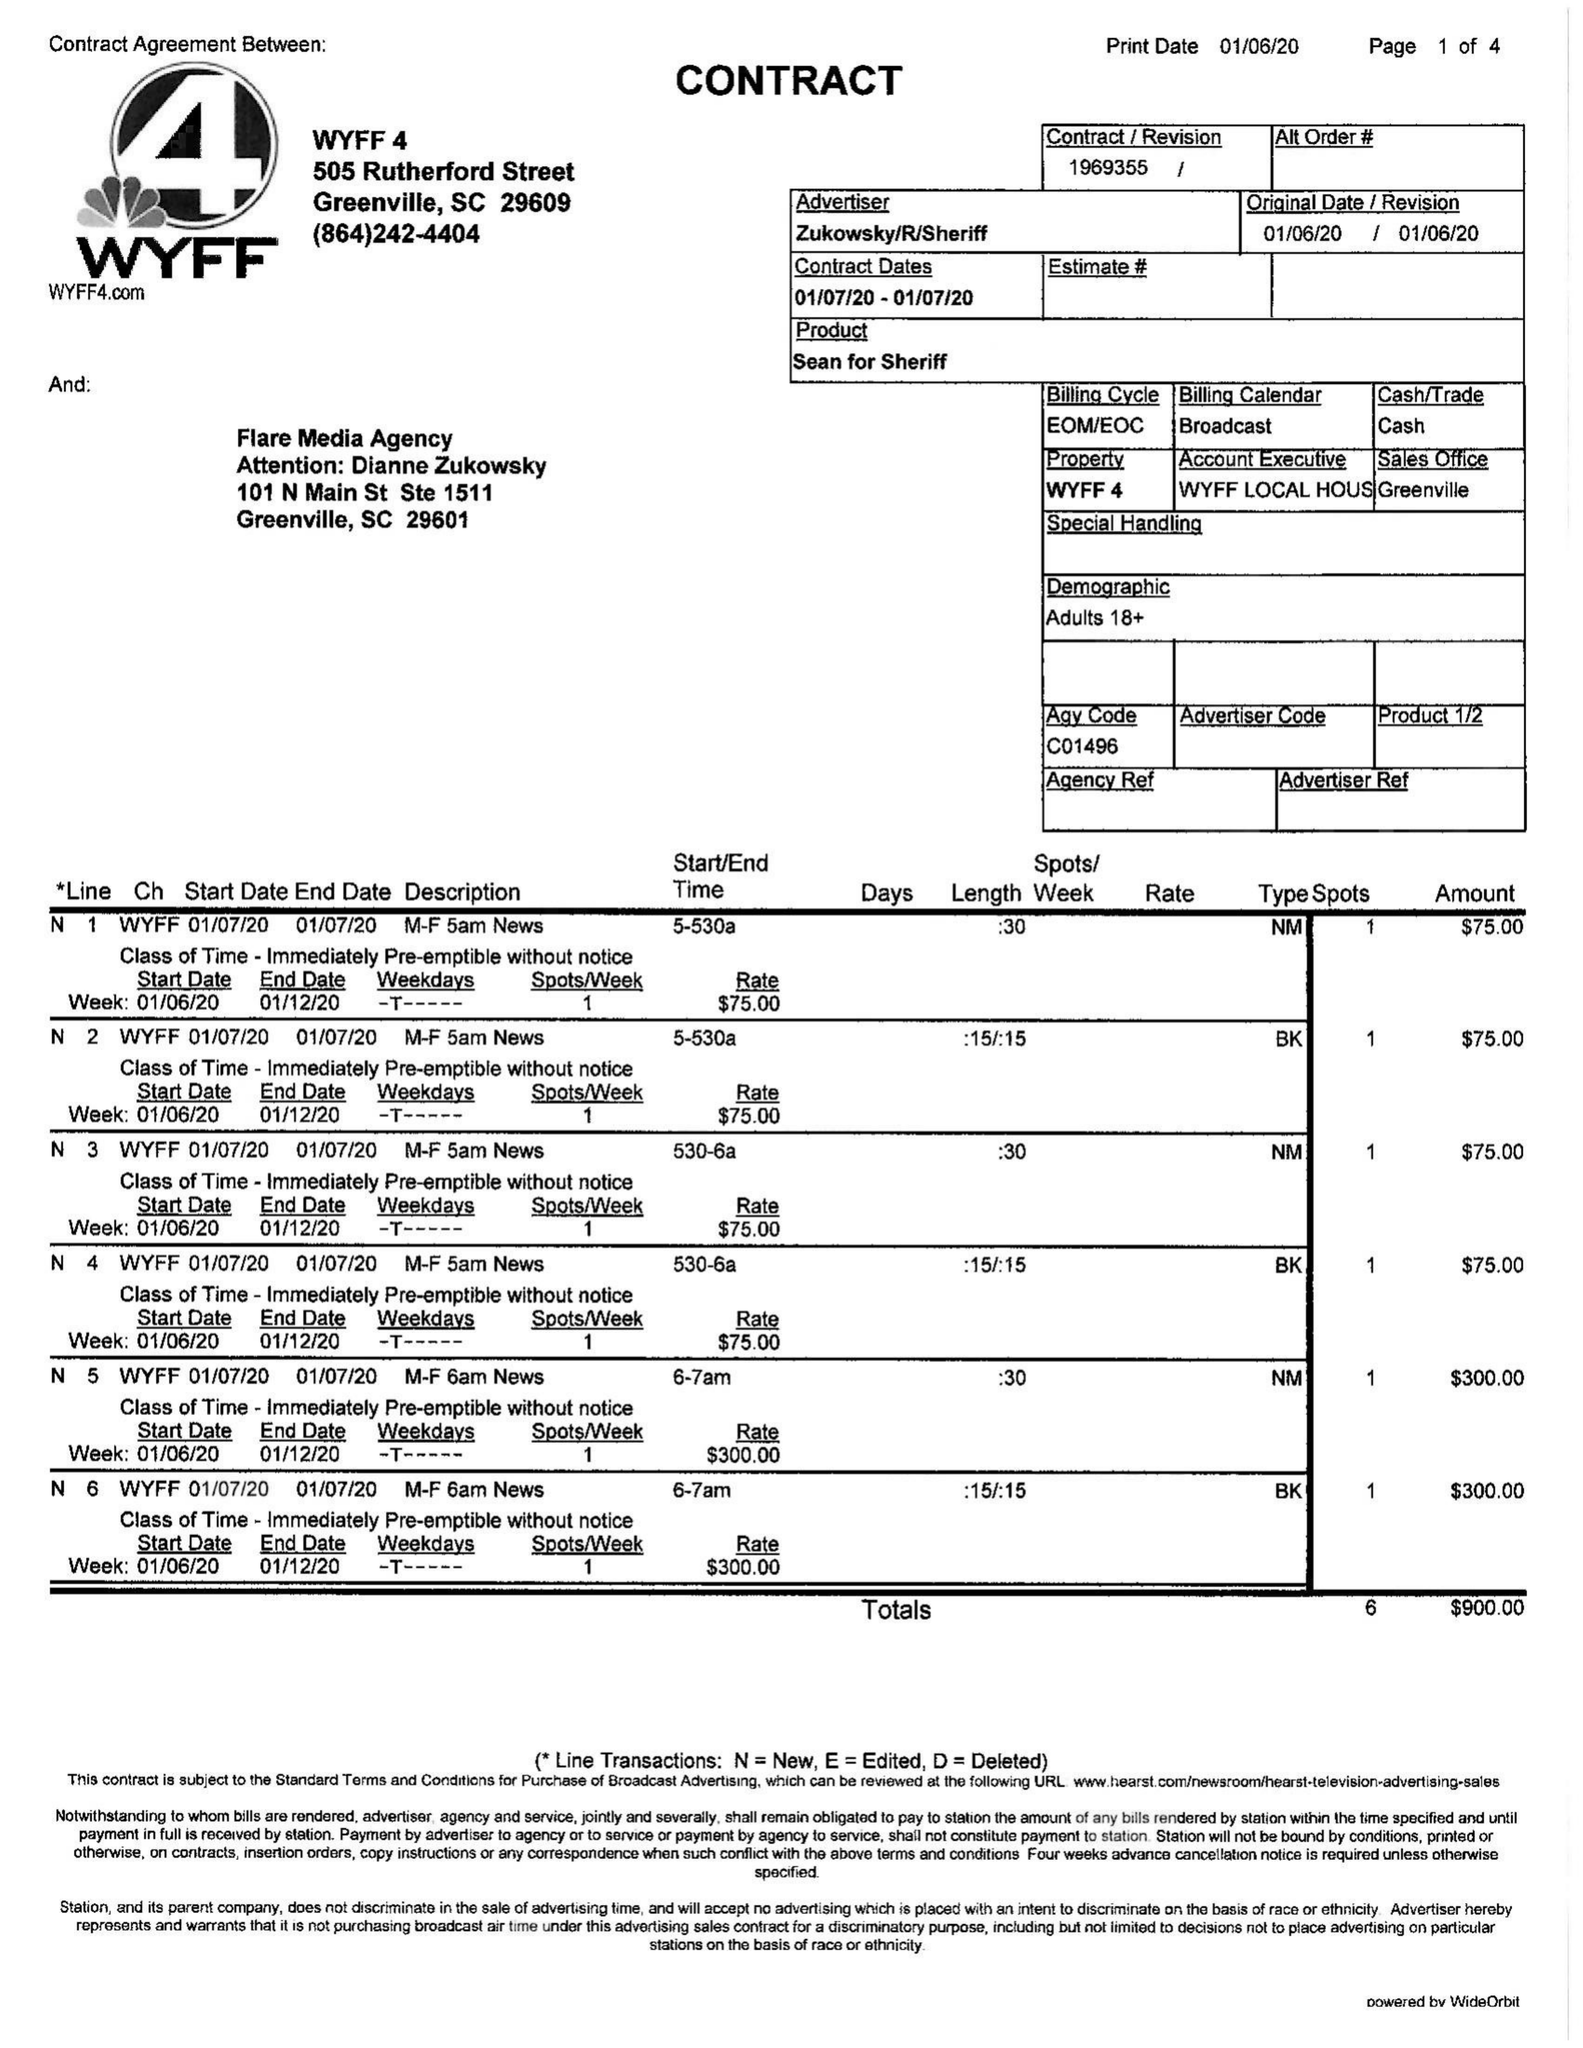What is the value for the flight_from?
Answer the question using a single word or phrase. 01/07/20 